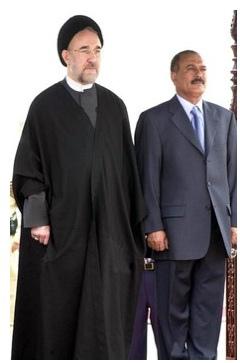Is anyone in the photo wearing glasses?
Quick response, please. Yes. Are the men clapping?
Concise answer only. No. What color is the man's turban?
Short answer required. Black. Are they both holding a paper in one of their hands?
Short answer required. No. 